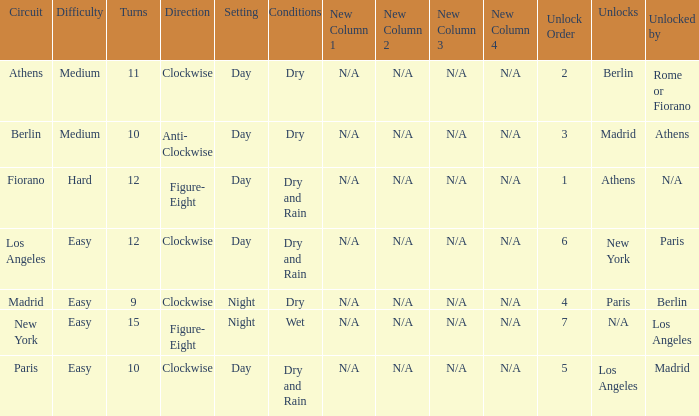How many instances is paris the unlock? 1.0. 